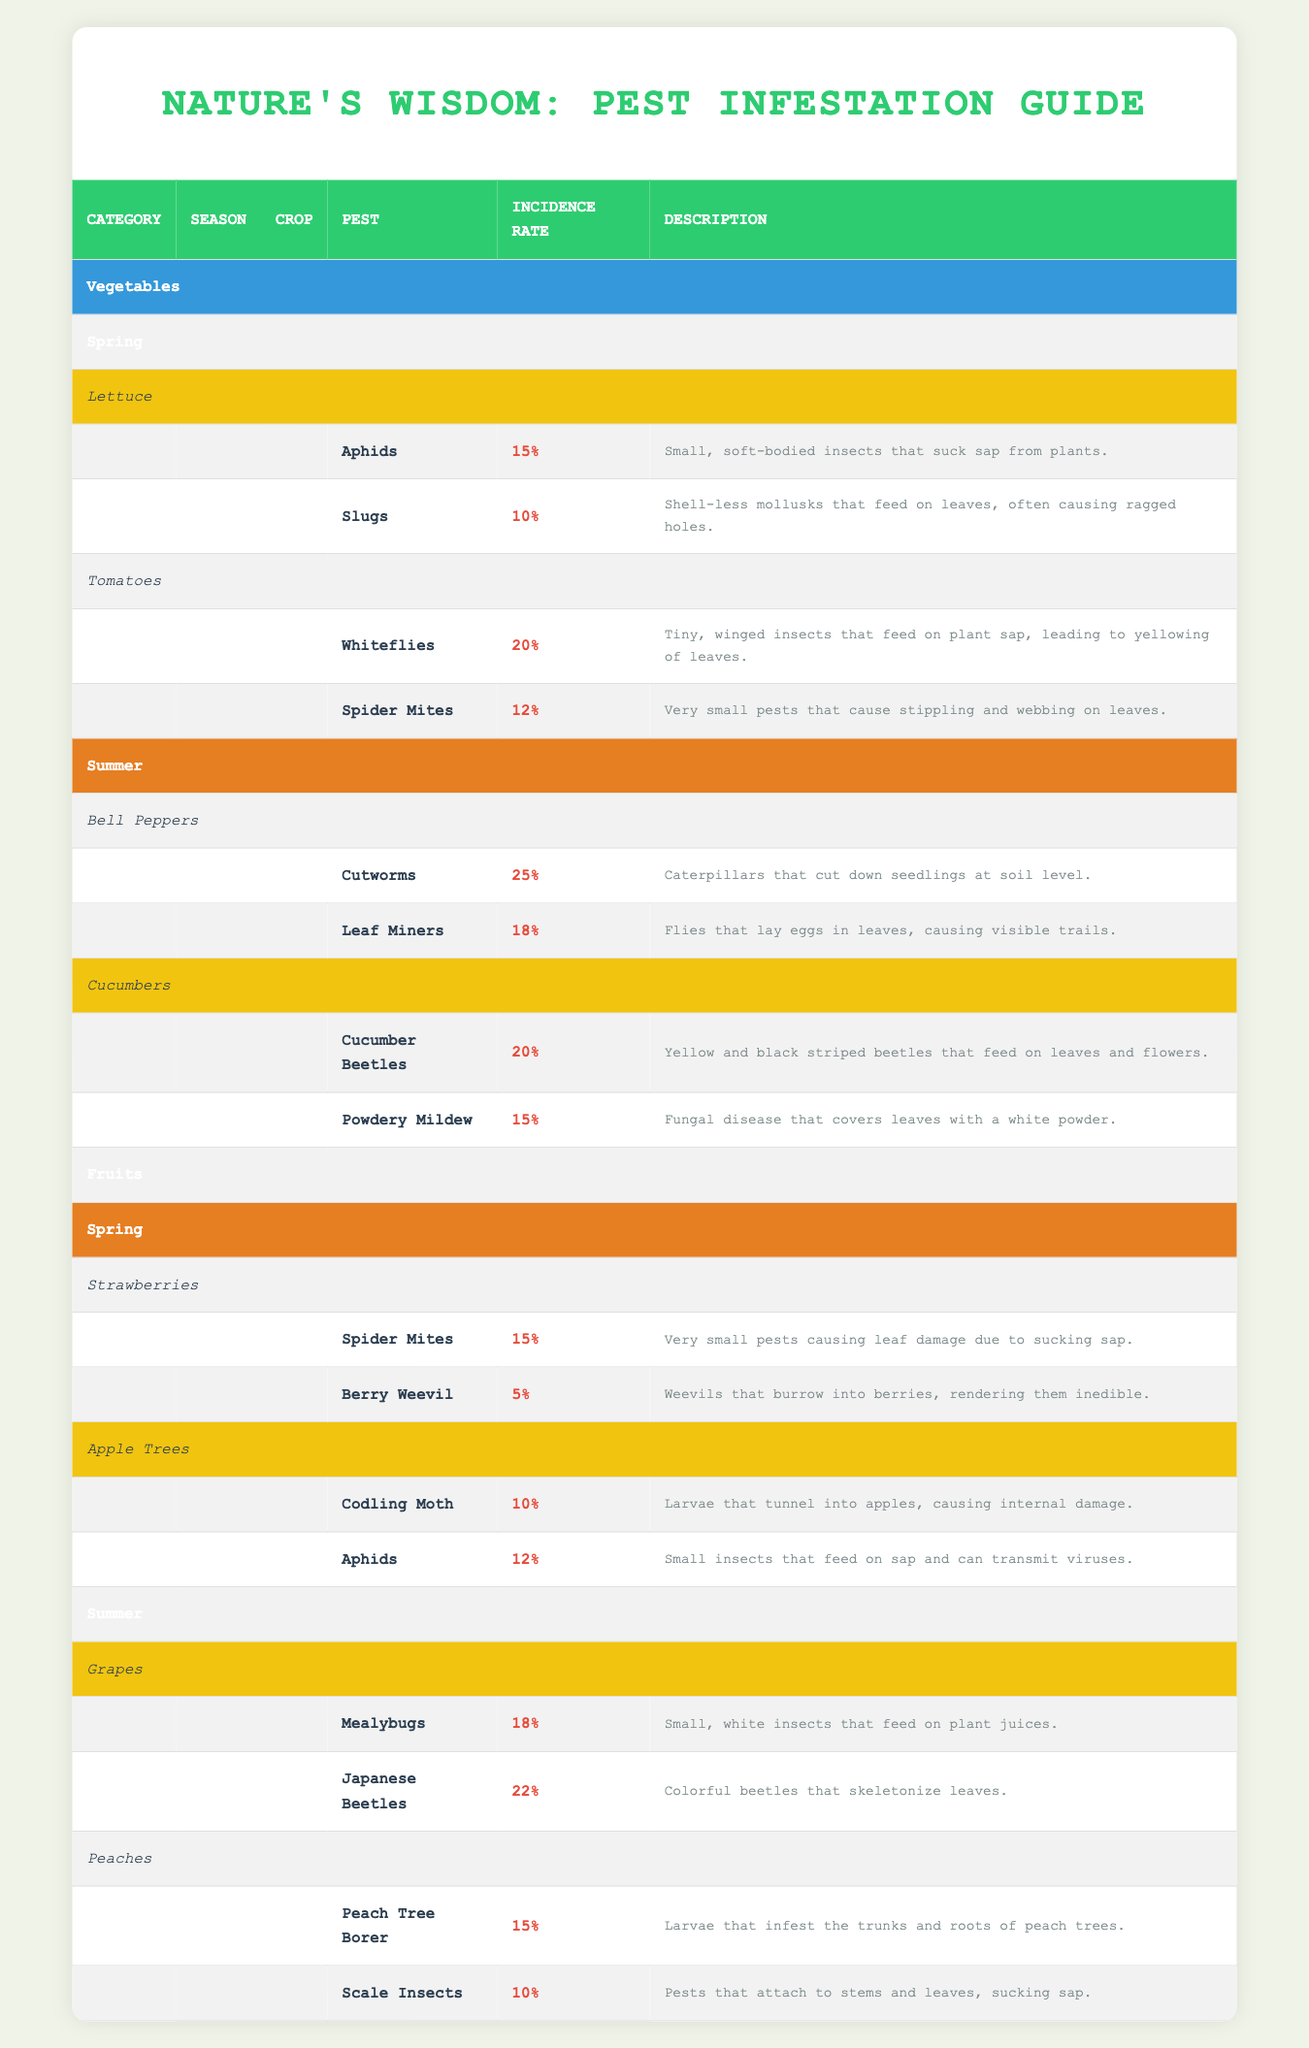What is the incidence rate of Aphids in Lettuce during Spring? Looking at the table under Vegetables, Spring, and then Lettuce, Aphids have an incidence rate of 15%.
Answer: 15% Which pest has the highest incidence rate in Bell Peppers during Summer? In the Summer section under Bell Peppers, Cutworms have an incidence rate of 25%, which is higher than Leaf Miners at 18%.
Answer: Cutworms Is the incidence rate of Spider Mites in Strawberries higher than in Lettuce? Spider Mites have an incidence rate of 15% in Strawberries and 12% in Lettuce, thus Spider Mites in Strawberries are higher.
Answer: Yes What is the average incidence rate of pests affecting Cucumber in Summer? The pests affecting Cucumbers are Cucumber Beetles at 20% and Powdery Mildew at 15%. Calculating the average gives (20 + 15) / 2 = 17.5%.
Answer: 17.5% Which crop has the lowest incidence rate of pests in Spring, and what is that rate? Looking through the Spring section, the pests in Strawberries include Spider Mites at 15% and Berry Weevil at 5%. The lower incidence rate is found in Berry Weevil, which is 5%.
Answer: Berry Weevil, 5% Are there any pests affecting Peaches during Summer? Checking the Summer section for Peaches, the table lists Peach Tree Borer at 15% and Scale Insects at 10%. Therefore, yes, there are pests affecting Peaches in Summer.
Answer: Yes How many pests are reported for Tomato crops in Spring? Looking at the Tomato crop under Spring, there are two reported pests: Whiteflies and Spider Mites. Therefore, there are 2 pests reported.
Answer: 2 What is the total incidence rate of pests for Apple Trees in Spring? For Apple Trees, there are Codling Moth at 10% and Aphids at 12%. Adding these together gives a total incidence rate of 10 + 12 = 22%.
Answer: 22% 